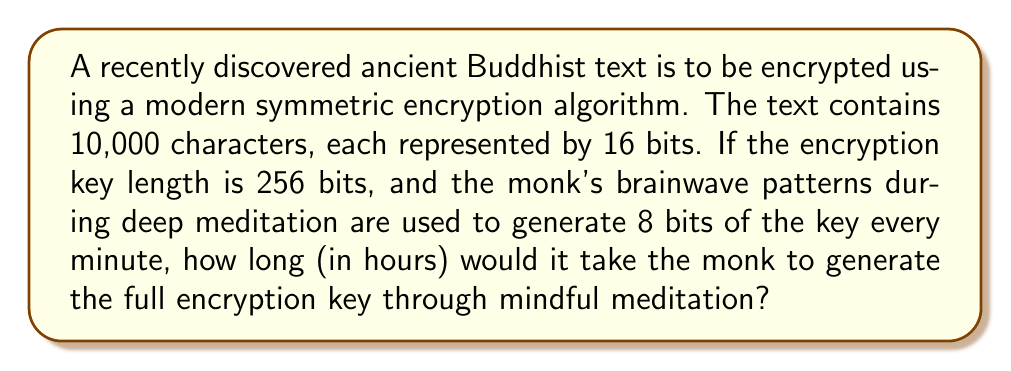Can you solve this math problem? To solve this problem, we'll follow these steps:

1) First, let's identify the key information:
   - The encryption key length is 256 bits
   - The monk generates 8 bits of the key every minute through meditation

2) Calculate how many minutes it takes to generate the full key:
   $$\text{Minutes needed} = \frac{\text{Total key length}}{\text{Bits generated per minute}}$$
   $$\text{Minutes needed} = \frac{256 \text{ bits}}{8 \text{ bits/minute}} = 32 \text{ minutes}$$

3) Convert minutes to hours:
   $$\text{Hours needed} = \frac{\text{Minutes needed}}{60 \text{ minutes/hour}}$$
   $$\text{Hours needed} = \frac{32 \text{ minutes}}{60 \text{ minutes/hour}} = \frac{8}{15} \text{ hours}$$

4) The final answer is $\frac{8}{15}$ hours, which can be expressed as a decimal:
   $$\frac{8}{15} = 0.5333... \text{ hours}$$

Note: The length of the text (10,000 characters of 16 bits each) doesn't affect the time needed to generate the key in this scenario.
Answer: $\frac{8}{15}$ hours 